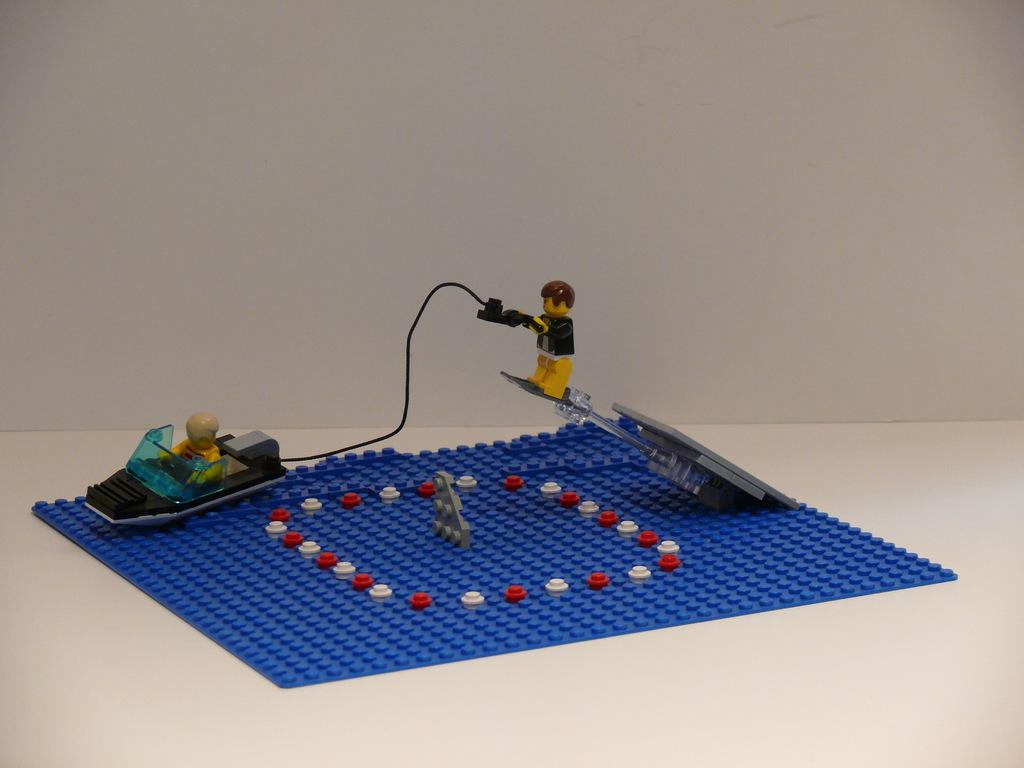What type of object is the main subject of the image? The main subject of the image is a miniature. Where is the miniature placed in the image? The miniature is kept on a desk. What color is the background of the image? The background of the image is white in color. Can you tell me how many boys are visible in the image? There are no boys present in the image; it features a miniature on a desk with a white background. What type of test is being conducted in the image? There is no test being conducted in the image; it only shows a miniature on a desk with a white background. 